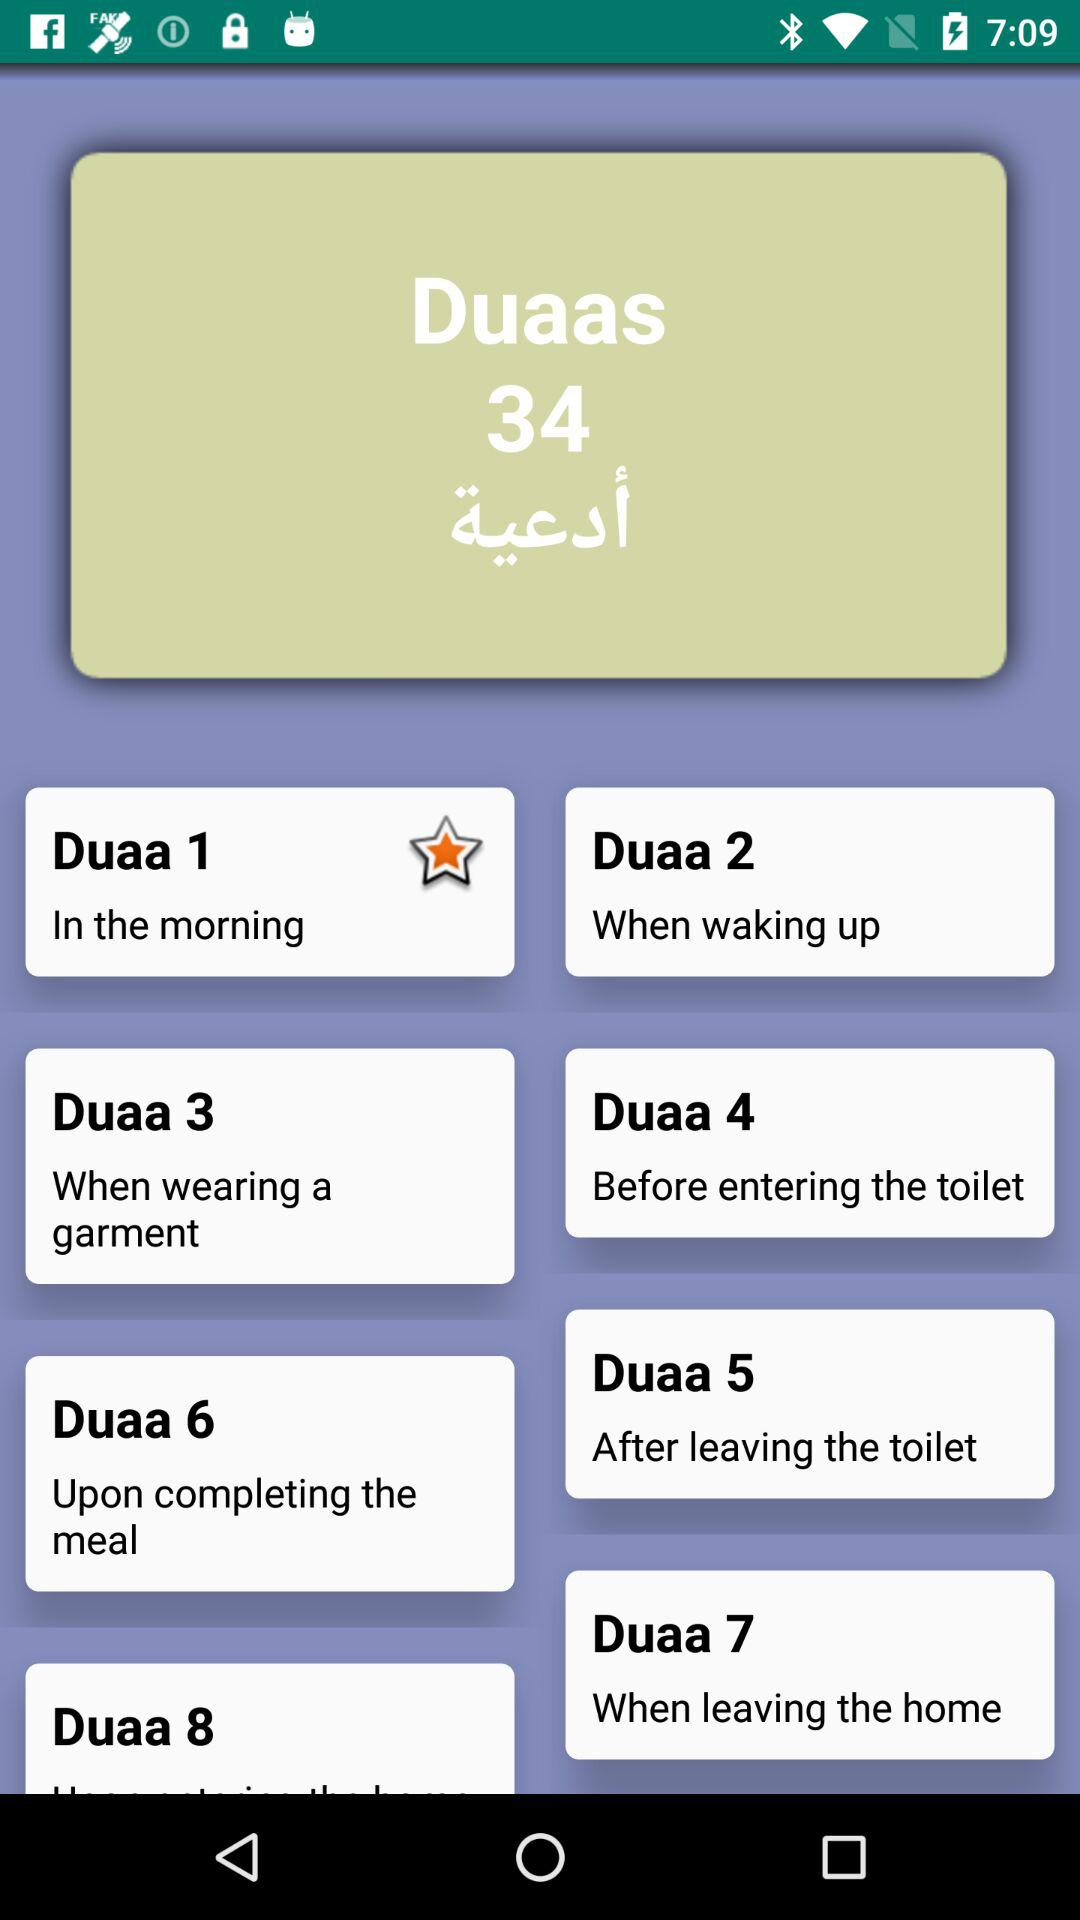When is "Duaa 1" recited? "Duaa 1" is recited in the morning. 